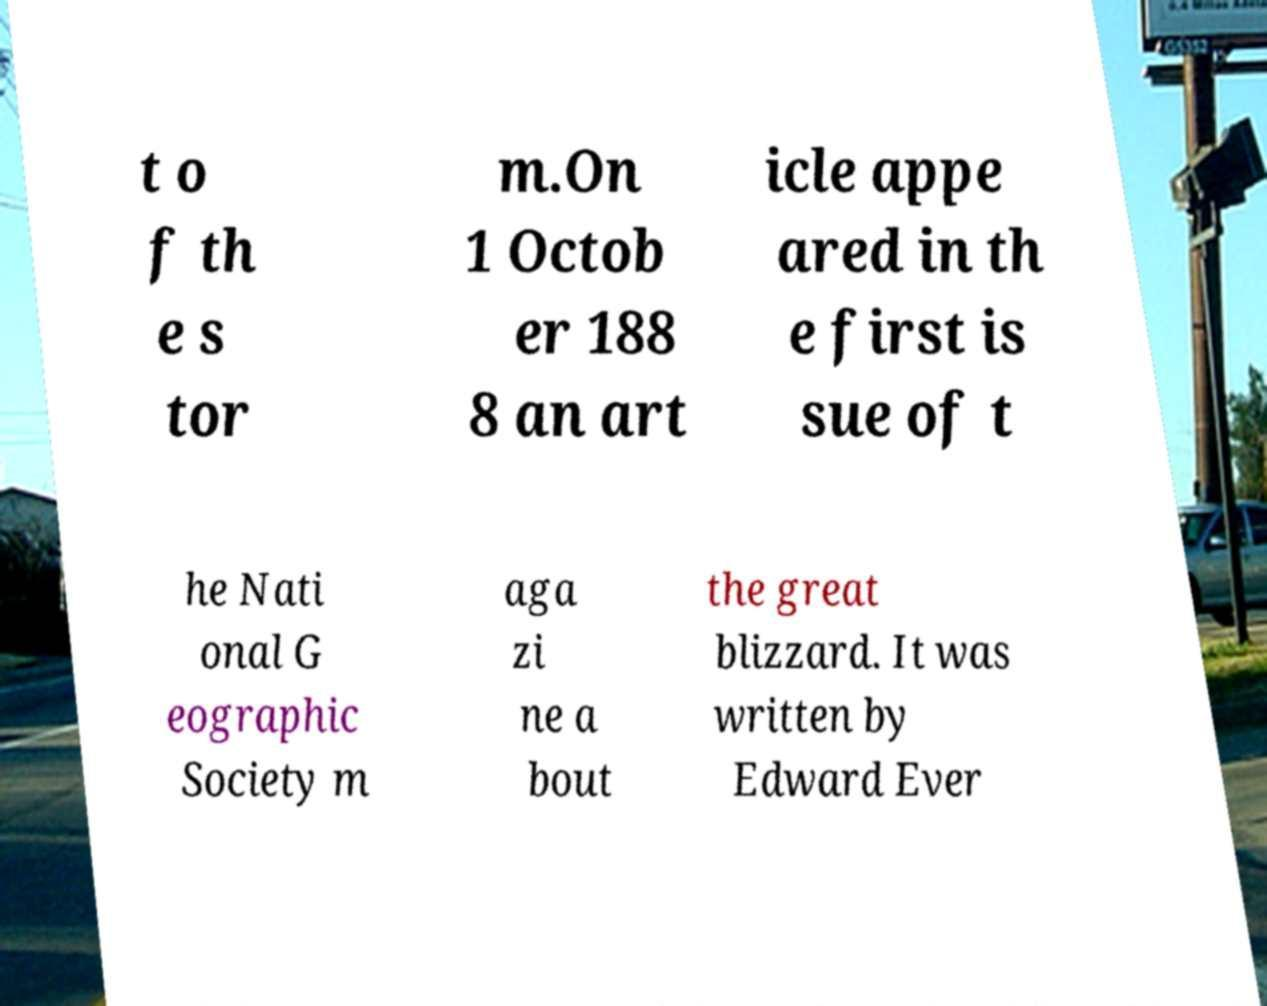I need the written content from this picture converted into text. Can you do that? t o f th e s tor m.On 1 Octob er 188 8 an art icle appe ared in th e first is sue of t he Nati onal G eographic Society m aga zi ne a bout the great blizzard. It was written by Edward Ever 